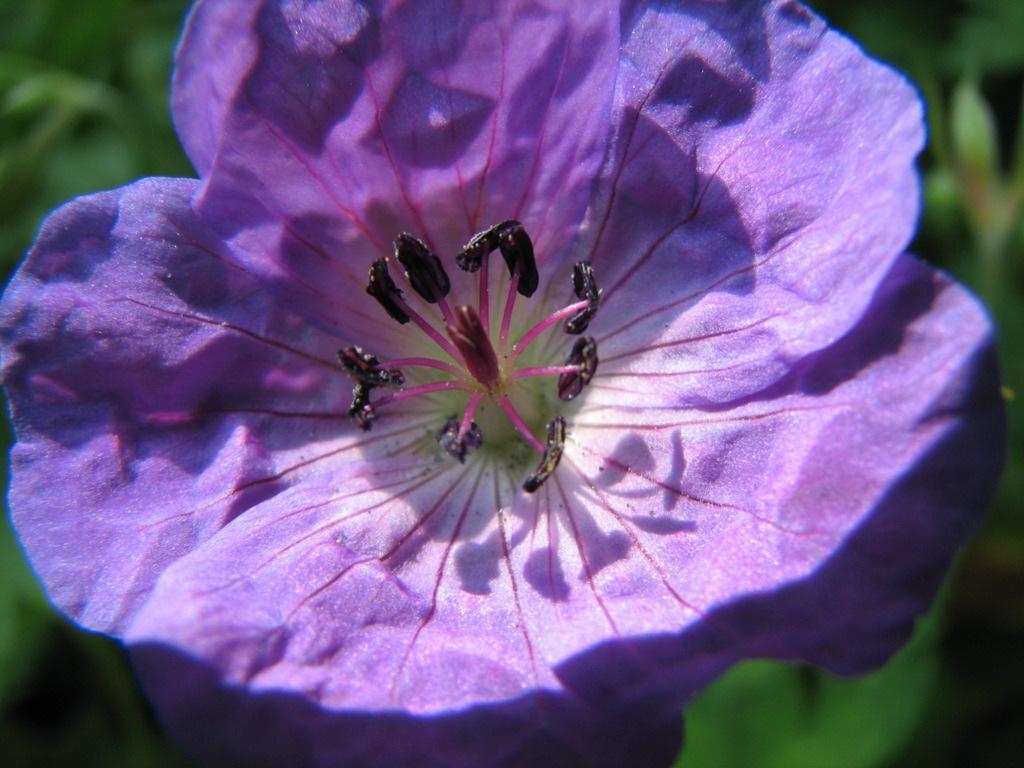Could you give a brief overview of what you see in this image? Here in this picture we can see a purple colored flower present over there and we can also see pollen grains in it. 